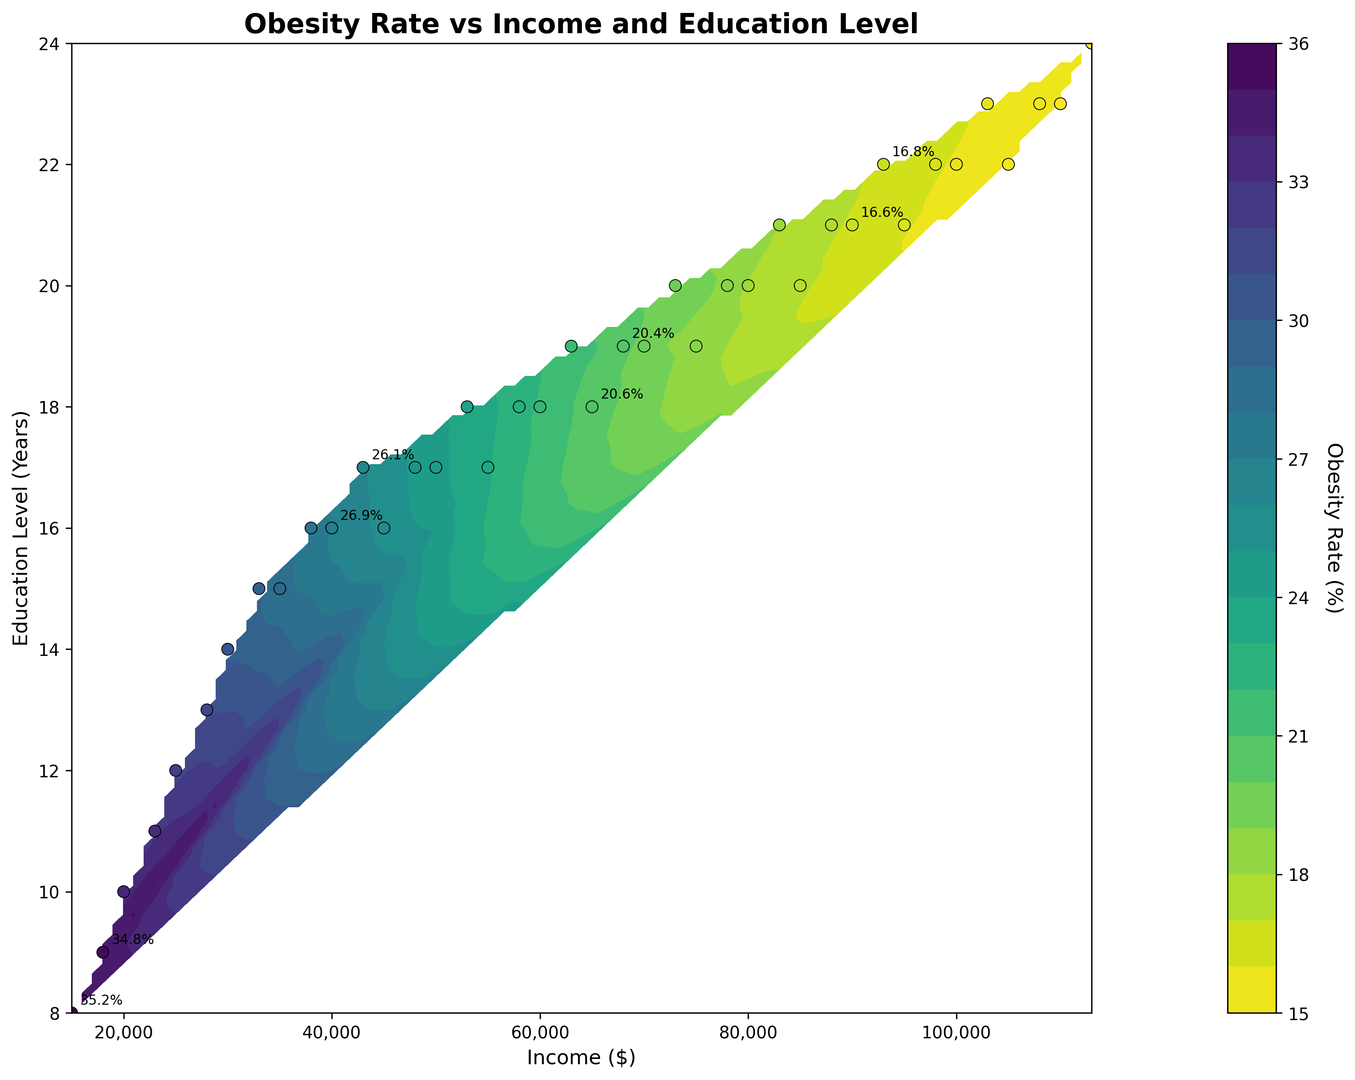What is the general trend of obesity rates as income increases? The plot visually shows the trend that as income increases (moving along the x-axis from left to right), the obesity rate generally decreases (indicated by the transitions to lighter colors).
Answer: Decreasing trend How does the educational level affect the obesity rate for the same income level of $50,000? For the income level of $50,000, as the educational level rises from 17 years to 18 years, the obesity rate decreases (indicated by lighter areas).
Answer: The obesity rate decreases Which region, low-income with low education or high-income with high education, has lower obesity rates? By observing the color gradients, the high-income with high education region (top-right) has lighter colors representing lower obesity rates compared to low-income with low education region (bottom-left) with darker colors.
Answer: High-income with high education Is the obesity rate more sensitive to changes in income or education level? By examining the density and spread of the contour lines, it is apparent that changes in income create more significant shifts in obesity rates compared to education level, with vertical gradients being more pronounced.
Answer: More sensitive to income At an income level of $70,000, what is the approximate obesity rate? Find the intersection of the income level $70,000 on the x-axis and observe the color shade corresponding to that area. The color indicates an approximate obesity rate of around 19.5%.
Answer: Approximately 19.5% For a given education level of 16 years, what range of income shows a noticeable decrease in obesity rates? By following the contour lines at 16 years of education level, a marked decrease in obesity rates occurs as income increases from $35,000 to $55,000 (indicated by lighter colors).
Answer: $35,000 to $55,000 Which has a steeper decrease in obesity rate, an increase in education from 16 to 18 years at $40,000, or from $80,000 to $100,000 rates at 20 years of education? Compare the slopes of the contour lines for the two ranges: the contour lines at income $40,000 show a steeper gradient compared to those at $80,000 to $100,000 with education level 20 years.
Answer: From $40,000 with education from 16 to 18 years What is the estimated obesity rate at the intersection of $85,000 income and 20 years of education? Locate the point with $85,000 income and 20 years of education on the plot, the color at that point suggests an obesity rate of around 17.2%.
Answer: Approximately 17.2% How does the obesity rate difference between education levels 18 and 20 years change with income levels from $60,000 to $80,000? Check the contour variation between education levels 18 and 20 across incomes from $60,000 to $80,000. The difference in obesity rate reduces as income increases (from lighter to darker shades, though not as distinctly).
Answer: Decreases as income increases 